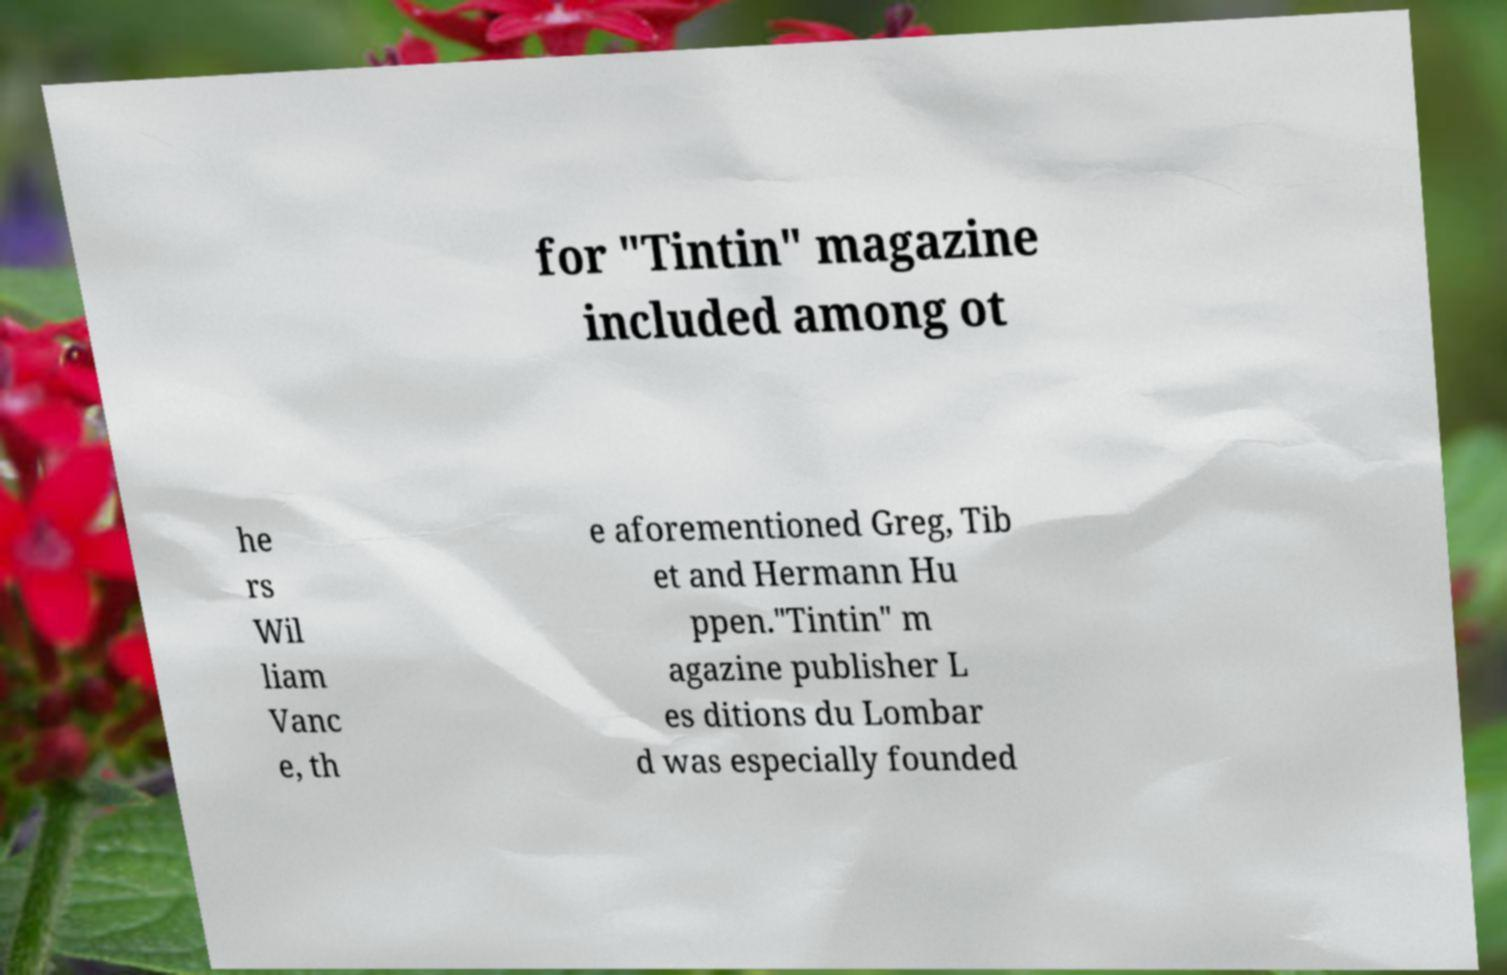Please read and relay the text visible in this image. What does it say? for "Tintin" magazine included among ot he rs Wil liam Vanc e, th e aforementioned Greg, Tib et and Hermann Hu ppen."Tintin" m agazine publisher L es ditions du Lombar d was especially founded 